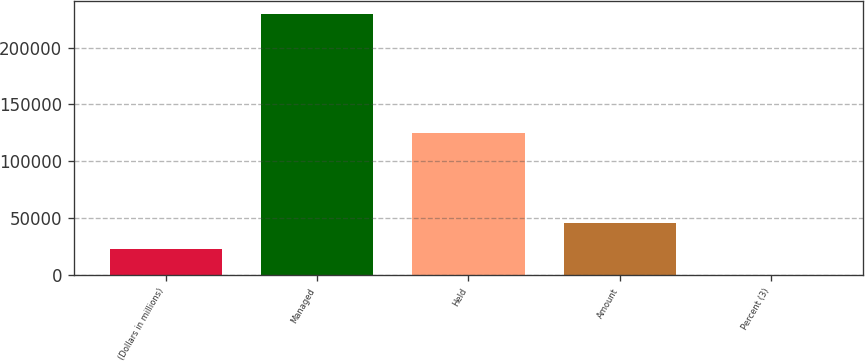Convert chart. <chart><loc_0><loc_0><loc_500><loc_500><bar_chart><fcel>(Dollars in millions)<fcel>Managed<fcel>Held<fcel>Amount<fcel>Percent (3)<nl><fcel>22940.7<fcel>229347<fcel>124946<fcel>45874.7<fcel>6.68<nl></chart> 